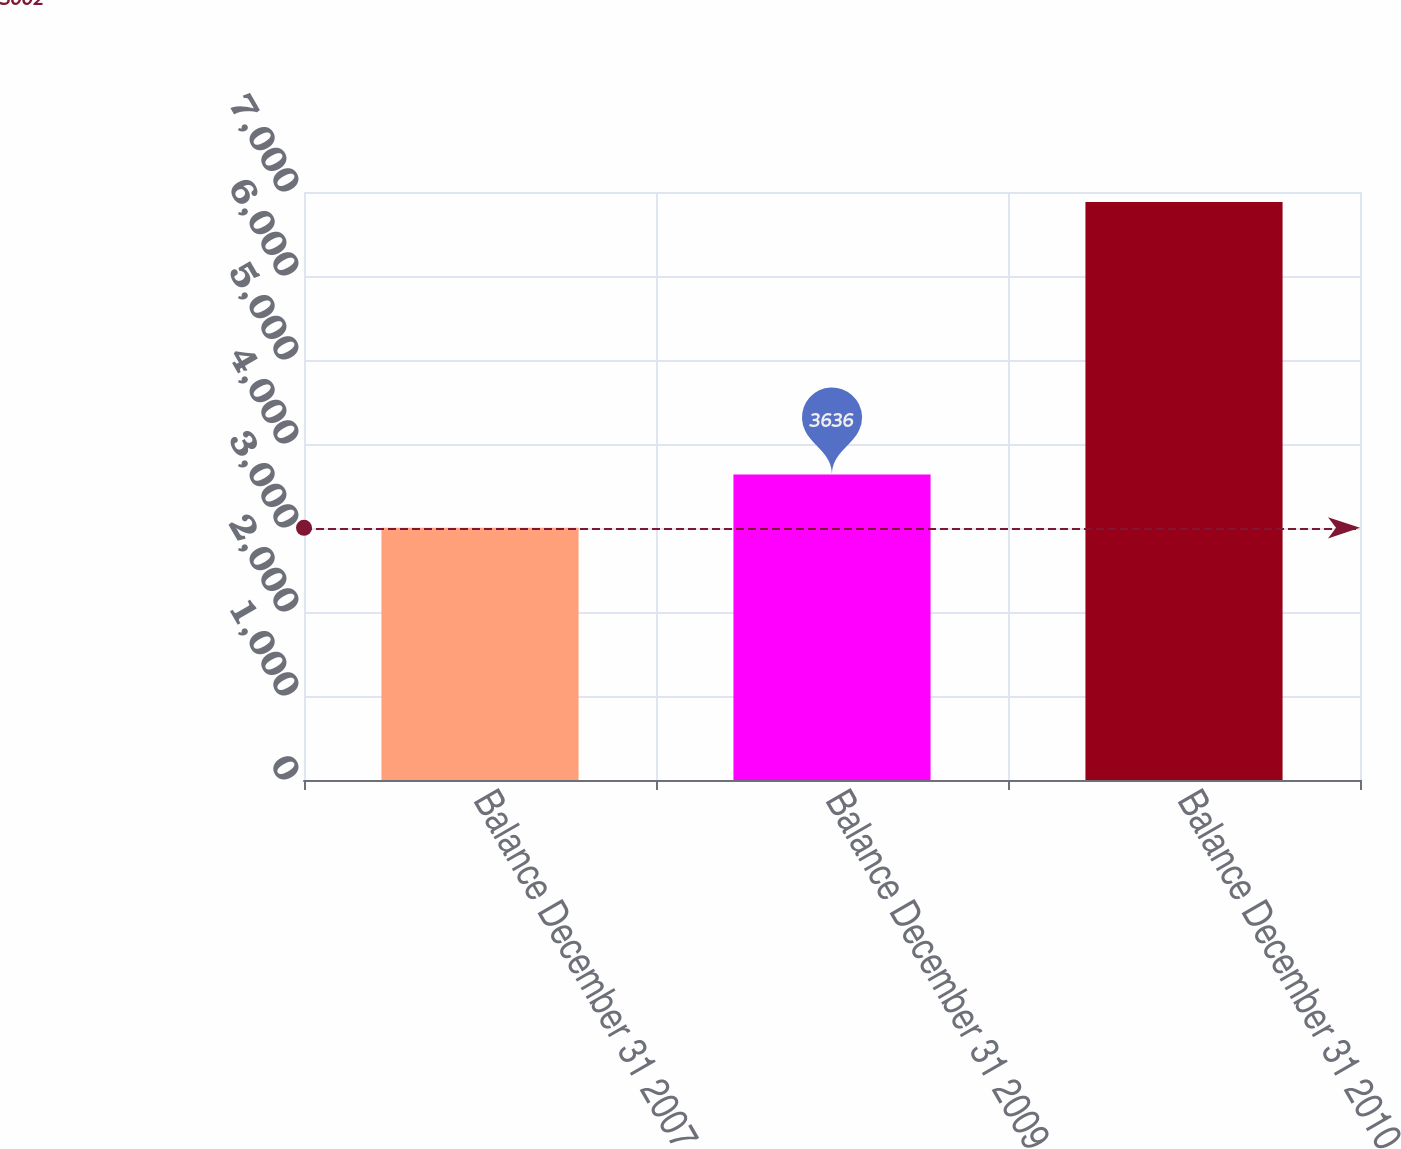<chart> <loc_0><loc_0><loc_500><loc_500><bar_chart><fcel>Balance December 31 2007<fcel>Balance December 31 2009<fcel>Balance December 31 2010<nl><fcel>3002<fcel>3636<fcel>6881<nl></chart> 